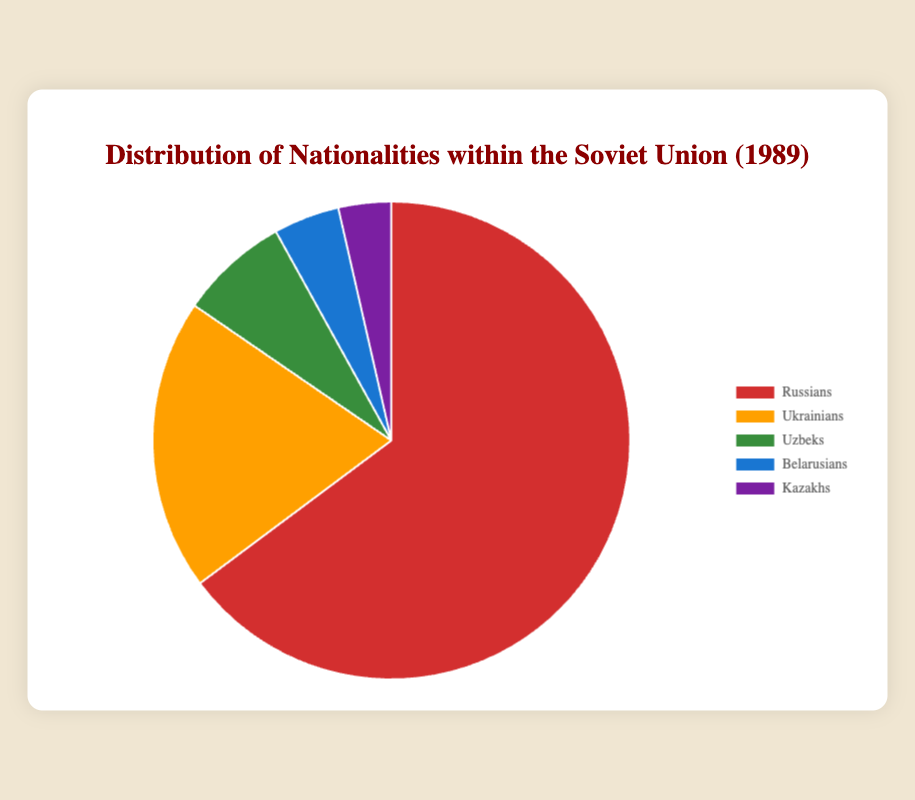what percentage of the Soviet Union's population did Belarusians and Kazakhs together constitute in 1989? Belarusians constituted 3.5% and Kazakhs constituted 2.8%. Adding these together (3.5 + 2.8), we get 6.3%.
Answer: 6.3% Which nationality had the smallest percentage in the distribution? By looking at the pie chart, we see that Kazakhs have the smallest segment, indicating they have the lowest percentage at 2.8%.
Answer: Kazakhs By how much does the percentage of Russians exceed the total percentage of Uzbeks and Belarusians combined? The percentage of Russians is 50.8%, Uzbeks is 5.8%, and Belarusians is 3.5%. Adding Uzbeks and Belarusians (5.8 + 3.5) equals 9.3%. Subtracting this sum from the percentage of Russians (50.8 - 9.3), we get 41.5%.
Answer: 41.5% Which two nationalities combined make up more than 20% of the population, but less than 25%? Ukrainians make up 15.5% and Uzbeks make up 5.8%. Adding them together (15.5 + 5.8), we get 21.3%, which falls between 20% and 25%.
Answer: Ukrainians and Uzbeks What is the percentage difference between the nationality with the highest percentage and the nationality with the lowest in the distribution? The highest percentage is 50.8% (Russians) and the lowest is 2.8% (Kazakhs). Subtracting these (50.8 - 2.8), we get 48%.
Answer: 48% Which slice of the pie chart is colored blue? By examining the colors in the legend, the slice colored blue corresponds to Belarusians.
Answer: Belarusians What percentage of the population do the non-Russian nationalities collectively represent? Adding the percentages of Ukrainians (15.5%), Uzbeks (5.8%), Belarusians (3.5%), and Kazakhs (2.8%), we obtain 27.6%.
Answer: 27.6% How does the percentage of Ukrainians compare to the percentage of Russians visually? The pie chart shows that the segment for Ukrainians is significantly smaller than the segment for Russians. Ukrainians constitute 15.5% while Russians constitute 50.8%, indicating Ukrainians' segment is much smaller.
Answer: Ukrainians' percentage is much smaller If you combine the percentage of Uzbeks and Belarusians, is it greater or less than the percentage of Ukrainians? The percentage of Uzbeks is 5.8% and Belarusians is 3.5%. Adding them together (5.8 + 3.5) equals 9.3%, which is less than the 15.5% of Ukrainians.
Answer: Less 